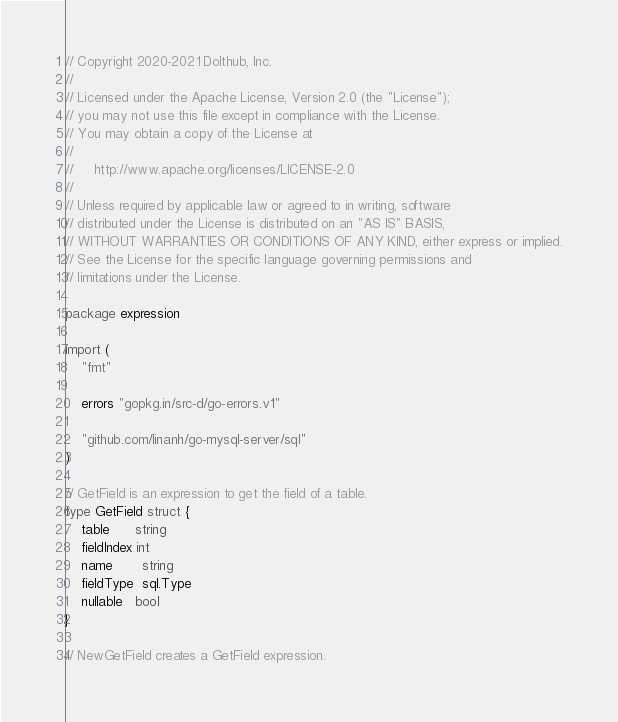Convert code to text. <code><loc_0><loc_0><loc_500><loc_500><_Go_>// Copyright 2020-2021 Dolthub, Inc.
//
// Licensed under the Apache License, Version 2.0 (the "License");
// you may not use this file except in compliance with the License.
// You may obtain a copy of the License at
//
//     http://www.apache.org/licenses/LICENSE-2.0
//
// Unless required by applicable law or agreed to in writing, software
// distributed under the License is distributed on an "AS IS" BASIS,
// WITHOUT WARRANTIES OR CONDITIONS OF ANY KIND, either express or implied.
// See the License for the specific language governing permissions and
// limitations under the License.

package expression

import (
	"fmt"

	errors "gopkg.in/src-d/go-errors.v1"

	"github.com/linanh/go-mysql-server/sql"
)

// GetField is an expression to get the field of a table.
type GetField struct {
	table      string
	fieldIndex int
	name       string
	fieldType  sql.Type
	nullable   bool
}

// NewGetField creates a GetField expression.</code> 